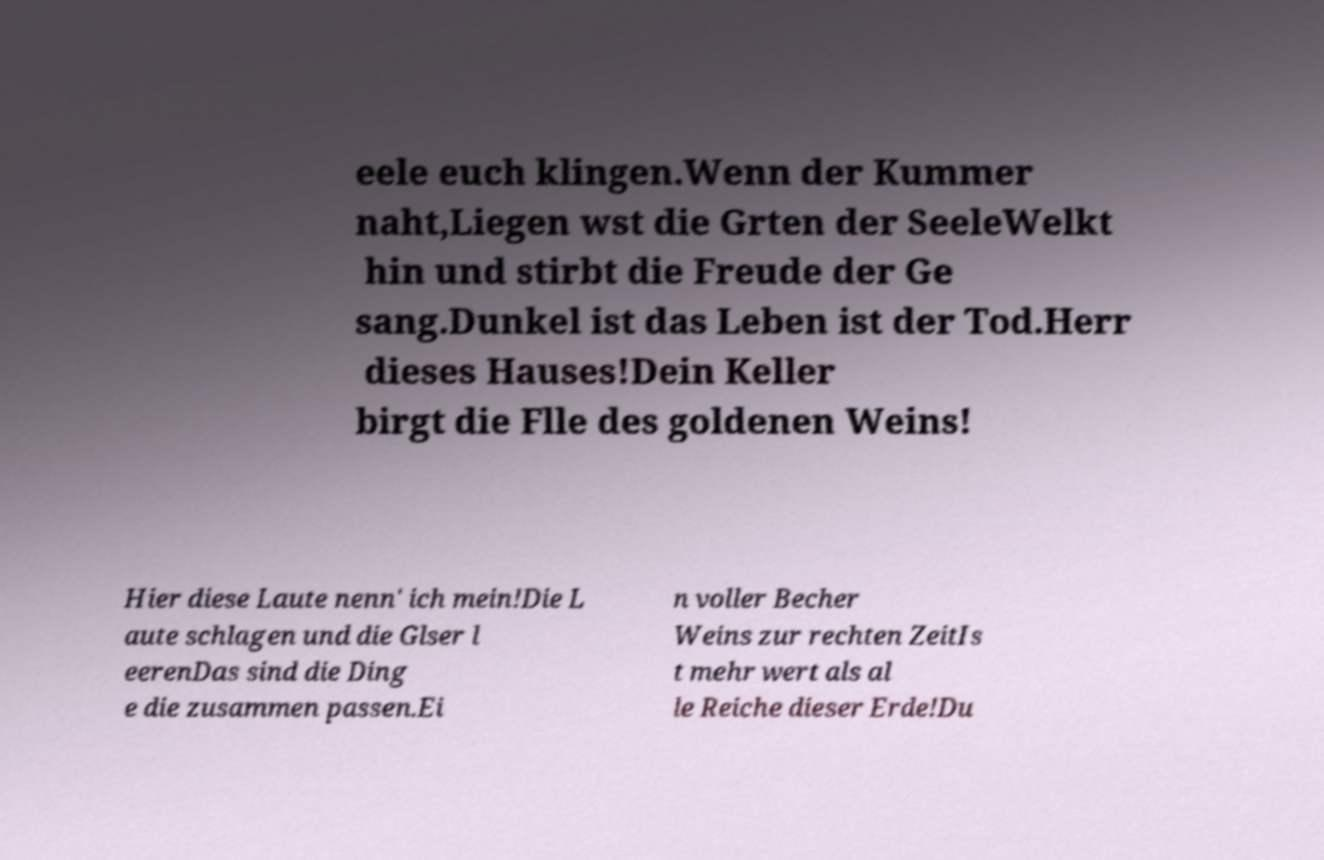For documentation purposes, I need the text within this image transcribed. Could you provide that? eele euch klingen.Wenn der Kummer naht,Liegen wst die Grten der SeeleWelkt hin und stirbt die Freude der Ge sang.Dunkel ist das Leben ist der Tod.Herr dieses Hauses!Dein Keller birgt die Flle des goldenen Weins! Hier diese Laute nenn' ich mein!Die L aute schlagen und die Glser l eerenDas sind die Ding e die zusammen passen.Ei n voller Becher Weins zur rechten ZeitIs t mehr wert als al le Reiche dieser Erde!Du 